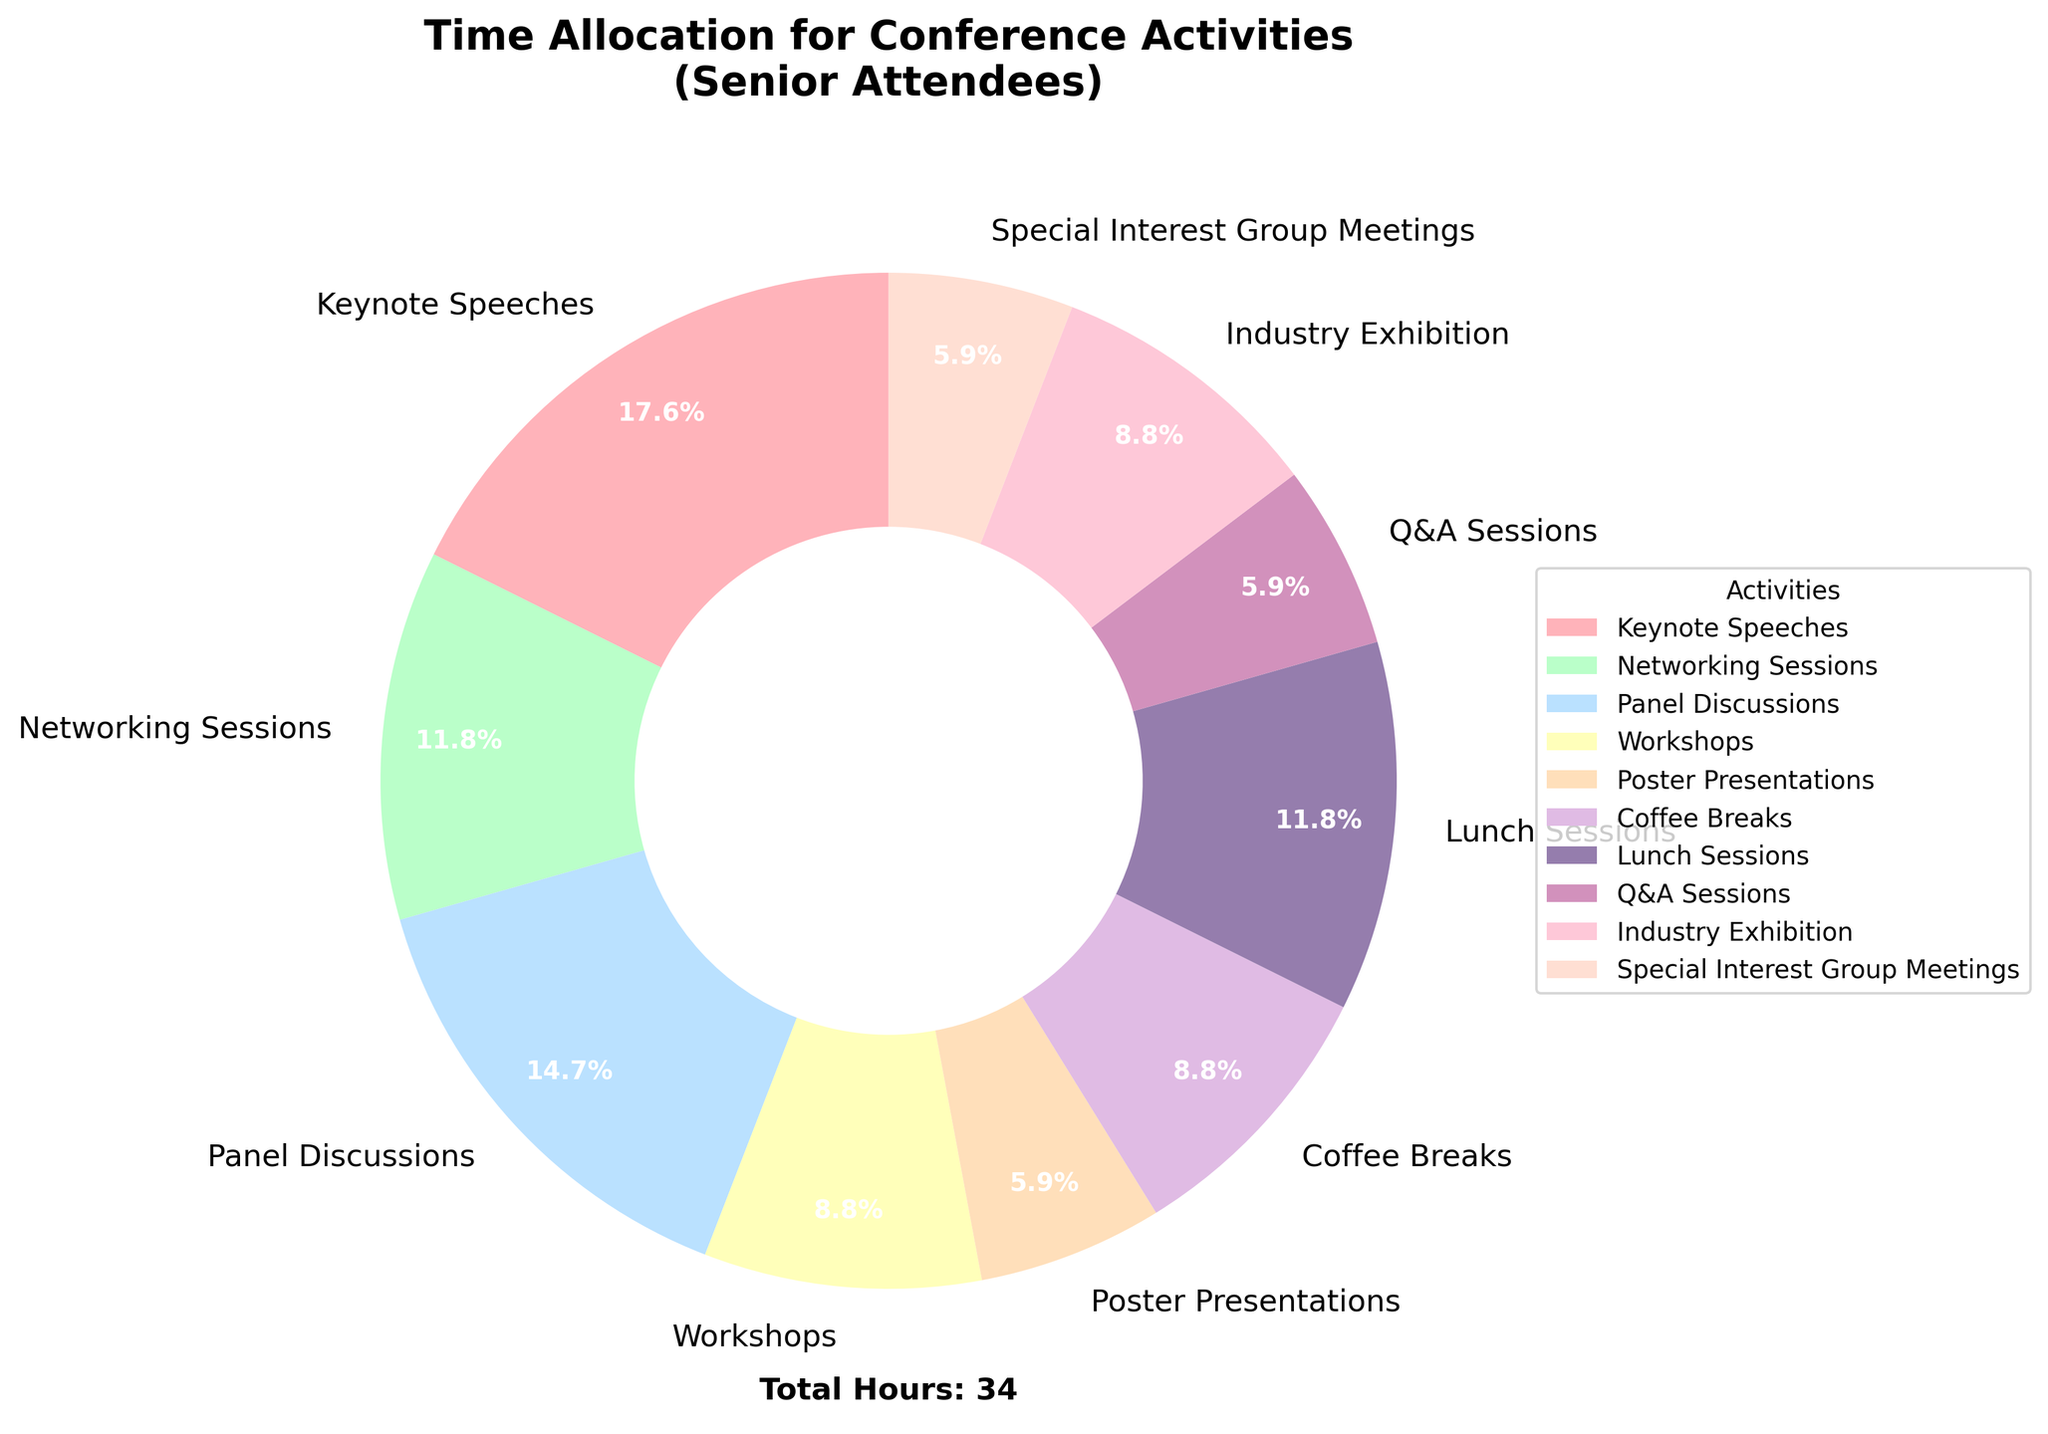What's the activity with the highest time allocation? Start by scanning the pie chart for the segment with the largest percentage label. The segment with the highest percentage is visually the largest slice.
Answer: Keynote Speeches What percentage of time is spent on Networking Sessions? Look at the label corresponding to Networking Sessions to find its percentage. Use the visual representation and text labels to confirm.
Answer: 16.7% How much more time is spent on Keynote Speeches than Poster Presentations? First, find time allocated to Keynote Speeches and Poster Presentations which are 6 and 2 hours respectively. Subtract the smaller value from the larger one: \(6 - 2\).
Answer: 4 hours Which activities occupy the smallest amount of time individually and what percentages do they represent? Identify activities with the smallest visual slices of the pie and read their percentages. Poster Presentations, Q&A Sessions, and Special Interest Group Meetings each have 2 hours.
Answer: 6.7% How does the time allocated to Workshops compare to Coffee Breaks? Observe the pie chart’s portions for both Workshops and Coffee Breaks and note the percentages: Workshops (10%) and Coffee Breaks (10%). Since both are visually equal, they hold the same percentage.
Answer: Equal (10%) What is the total percentage of time allocated to Panel Discussions and Lunch Sessions combined? Find the percentages for both Panel Discussions (16.7%) and Lunch Sessions (13.3%) and sum them up: \(16.7 + 13.3\).
Answer: 30% Which activity with a green visual representation and how much time is allocated to it? Identify the segment in green on the chart. Networking Sessions is the activity in green, which according to the visual representation, is 4 hours.
Answer: Networking Sessions, 4 hours If two hours were removed from Keynote Speeches and added to Q&A Sessions, what would be the new total hours for these activities? Recalculate the total hours for Keynote Speeches as \(6 - 2 = 4\) and for Q&A Sessions as \(2 + 2 = 4\). The combined new total for both is \(4 + 4\).
Answer: 8 hours How many hours are spent on Industry Exhibition and Coffee Breaks combined? Locate the hours for Industry Exhibition (3) and Coffee Breaks (3) on the pie chart and sum them: \(3 + 3\).
Answer: 6 hours What fraction of the total time is dedicated to Q&A Sessions? Identify the hours spent on Q&A Sessions (2) and divide this by the total hours of all activities (34): \(2/34 = 1/17\).
Answer: 1/17 